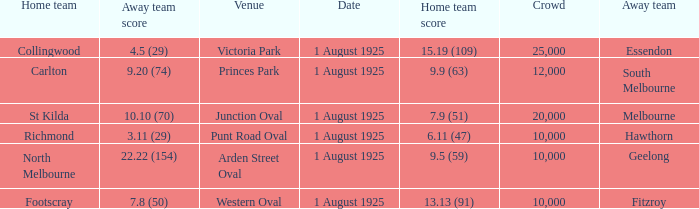At the match where the away team scored 4.5 (29), what was the crowd size? 1.0. 